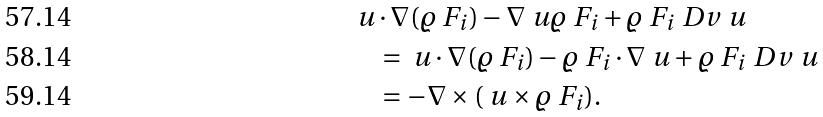<formula> <loc_0><loc_0><loc_500><loc_500>& \ u \cdot \nabla ( \varrho \ F _ { i } ) - \nabla \ u \varrho \ F _ { i } + \varrho \ F _ { i } \ D v \ u \\ & \quad = \ u \cdot \nabla ( \varrho \ F _ { i } ) - \varrho \ F _ { i } \cdot \nabla \ u + \varrho \ F _ { i } \ D v \ u \\ & \quad = - \nabla \times ( \ u \times \varrho \ F _ { i } ) .</formula> 